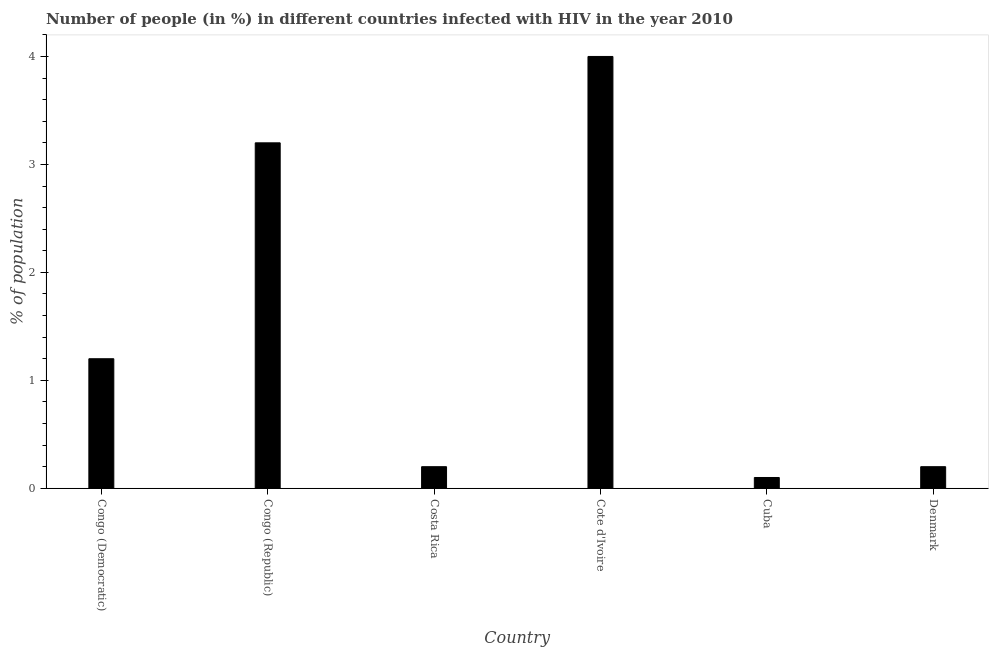Does the graph contain any zero values?
Make the answer very short. No. What is the title of the graph?
Ensure brevity in your answer.  Number of people (in %) in different countries infected with HIV in the year 2010. What is the label or title of the X-axis?
Offer a terse response. Country. What is the label or title of the Y-axis?
Your answer should be very brief. % of population. What is the number of people infected with hiv in Costa Rica?
Your answer should be very brief. 0.2. Across all countries, what is the maximum number of people infected with hiv?
Keep it short and to the point. 4. In which country was the number of people infected with hiv maximum?
Offer a terse response. Cote d'Ivoire. In which country was the number of people infected with hiv minimum?
Ensure brevity in your answer.  Cuba. What is the sum of the number of people infected with hiv?
Your answer should be very brief. 8.9. What is the average number of people infected with hiv per country?
Make the answer very short. 1.48. Is the sum of the number of people infected with hiv in Cote d'Ivoire and Cuba greater than the maximum number of people infected with hiv across all countries?
Give a very brief answer. Yes. In how many countries, is the number of people infected with hiv greater than the average number of people infected with hiv taken over all countries?
Provide a short and direct response. 2. How many bars are there?
Make the answer very short. 6. Are all the bars in the graph horizontal?
Provide a succinct answer. No. How many countries are there in the graph?
Provide a succinct answer. 6. What is the difference between two consecutive major ticks on the Y-axis?
Offer a very short reply. 1. Are the values on the major ticks of Y-axis written in scientific E-notation?
Provide a short and direct response. No. What is the % of population in Congo (Democratic)?
Make the answer very short. 1.2. What is the % of population of Congo (Republic)?
Provide a succinct answer. 3.2. What is the % of population in Costa Rica?
Your response must be concise. 0.2. What is the % of population in Cote d'Ivoire?
Provide a succinct answer. 4. What is the difference between the % of population in Congo (Democratic) and Denmark?
Your answer should be compact. 1. What is the difference between the % of population in Congo (Republic) and Costa Rica?
Your answer should be compact. 3. What is the difference between the % of population in Congo (Republic) and Denmark?
Give a very brief answer. 3. What is the difference between the % of population in Costa Rica and Cote d'Ivoire?
Offer a terse response. -3.8. What is the difference between the % of population in Costa Rica and Denmark?
Offer a terse response. 0. What is the difference between the % of population in Cuba and Denmark?
Offer a terse response. -0.1. What is the ratio of the % of population in Congo (Democratic) to that in Costa Rica?
Your answer should be compact. 6. What is the ratio of the % of population in Congo (Republic) to that in Cote d'Ivoire?
Offer a very short reply. 0.8. What is the ratio of the % of population in Congo (Republic) to that in Cuba?
Make the answer very short. 32. What is the ratio of the % of population in Costa Rica to that in Cuba?
Your answer should be very brief. 2. What is the ratio of the % of population in Cote d'Ivoire to that in Denmark?
Your answer should be compact. 20. 